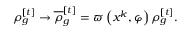Convert formula to latex. <formula><loc_0><loc_0><loc_500><loc_500>\rho _ { g } ^ { [ t ] } \rightarrow \overline { \rho } _ { g } ^ { [ t ] } = \varpi \left ( x ^ { k } , \varphi \right ) \rho _ { g } ^ { [ t ] } .</formula> 